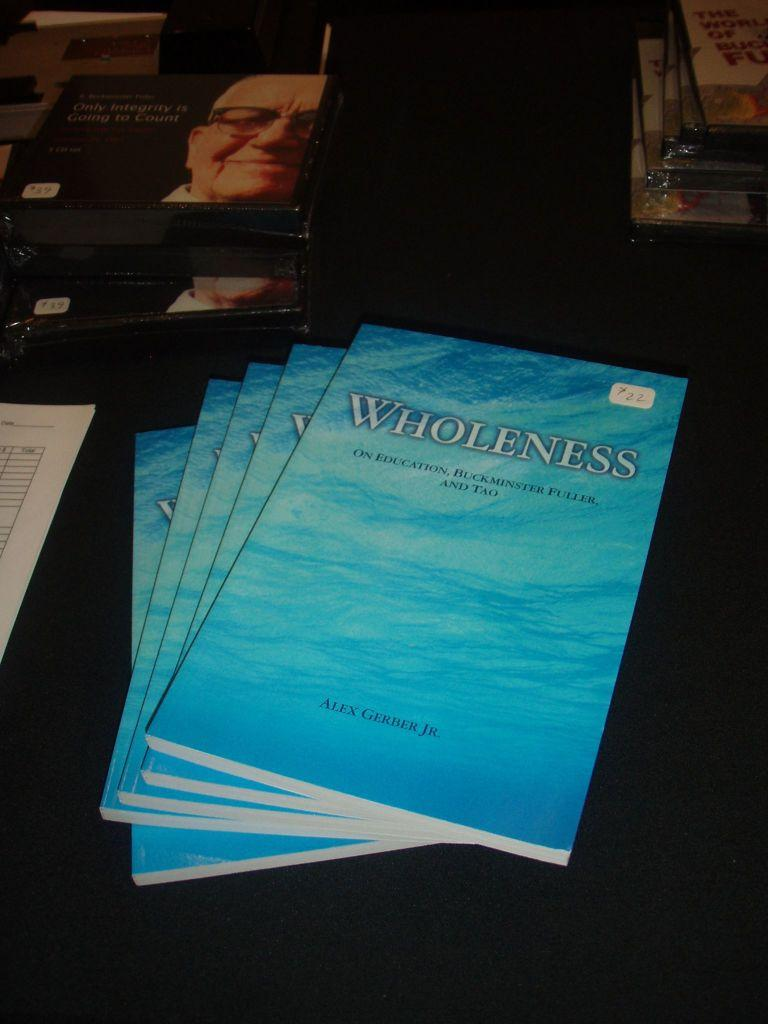<image>
Share a concise interpretation of the image provided. A stack of blue books on Wholeness sits next to other items on a table. 